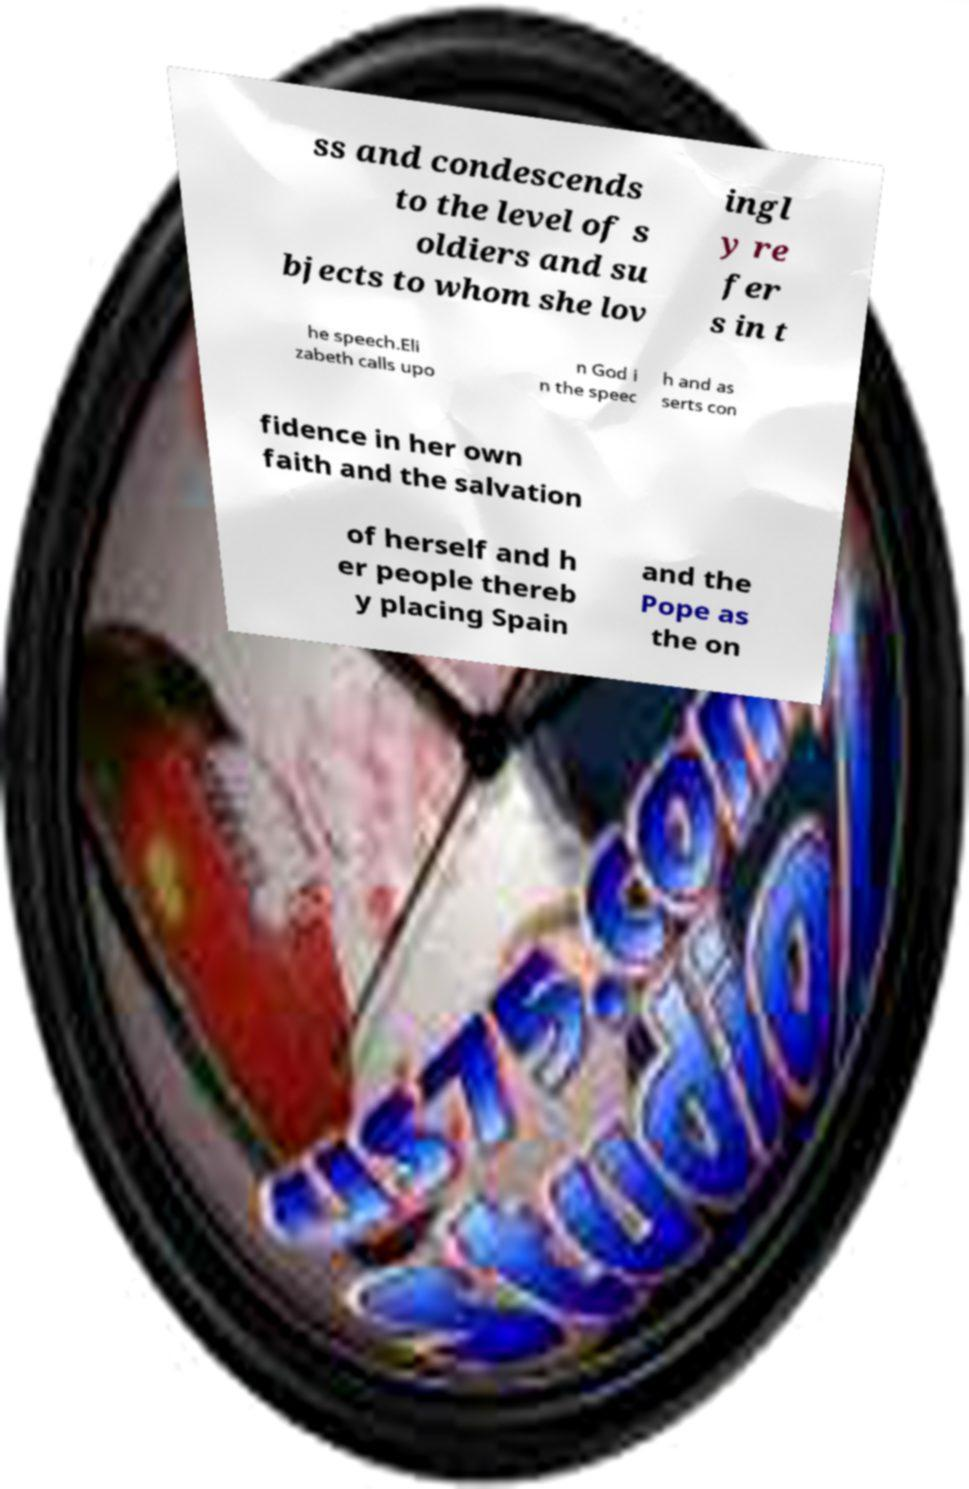Can you accurately transcribe the text from the provided image for me? ss and condescends to the level of s oldiers and su bjects to whom she lov ingl y re fer s in t he speech.Eli zabeth calls upo n God i n the speec h and as serts con fidence in her own faith and the salvation of herself and h er people thereb y placing Spain and the Pope as the on 